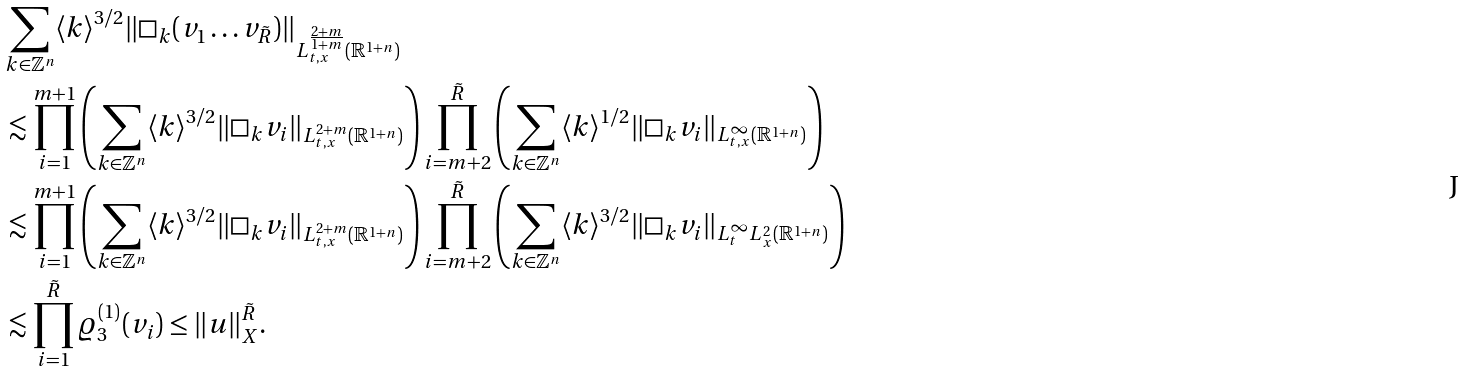<formula> <loc_0><loc_0><loc_500><loc_500>& \sum _ { k \in \mathbb { Z } ^ { n } } \langle k \rangle ^ { 3 / 2 } \| \Box _ { k } ( v _ { 1 } \dots v _ { \tilde { R } } ) \| _ { L ^ { \frac { 2 + m } { 1 + m } } _ { t , x } ( \mathbb { R } ^ { 1 + n } ) } \\ & \lesssim \prod ^ { m + 1 } _ { i = 1 } \left ( \sum _ { k \in \mathbb { Z } ^ { n } } \langle k \rangle ^ { 3 / 2 } \| \Box _ { k } v _ { i } \| _ { L ^ { 2 + m } _ { t , x } ( \mathbb { R } ^ { 1 + n } ) } \right ) \prod ^ { \tilde { R } } _ { i = m + 2 } \left ( \sum _ { k \in \mathbb { Z } ^ { n } } \langle k \rangle ^ { 1 / 2 } \| \Box _ { k } v _ { i } \| _ { L ^ { \infty } _ { t , x } ( \mathbb { R } ^ { 1 + n } ) } \right ) \\ & \lesssim \prod ^ { m + 1 } _ { i = 1 } \left ( \sum _ { k \in \mathbb { Z } ^ { n } } \langle k \rangle ^ { 3 / 2 } \| \Box _ { k } v _ { i } \| _ { L ^ { 2 + m } _ { t , x } ( \mathbb { R } ^ { 1 + n } ) } \right ) \prod ^ { \tilde { R } } _ { i = m + 2 } \left ( \sum _ { k \in \mathbb { Z } ^ { n } } \langle k \rangle ^ { 3 / 2 } \| \Box _ { k } v _ { i } \| _ { L ^ { \infty } _ { t } L ^ { 2 } _ { x } ( \mathbb { R } ^ { 1 + n } ) } \right ) \\ & \lesssim \prod ^ { \tilde { R } } _ { i = 1 } \varrho ^ { ( 1 ) } _ { 3 } ( v _ { i } ) \leq \| u \| ^ { \tilde { R } } _ { X } .</formula> 